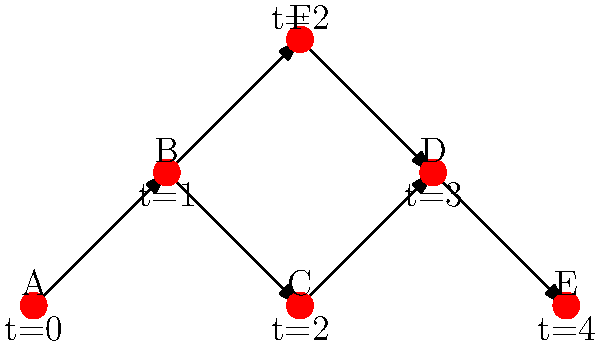In the given cloud instance network diagram, a cyber attack originates at instance A and propagates through the network. Each edge represents a connection between instances, and the time (t) indicates when each instance becomes infected. What is the minimum number of instances that need to be isolated to completely contain the spread of the attack after time t=2? To solve this problem, we need to analyze the propagation of the attack and identify the critical nodes that, if isolated, would prevent further spread. Let's break it down step-by-step:

1. At t=0, instance A is infected.
2. At t=1, the attack spreads to instance B.
3. At t=2, the attack reaches instances C and F simultaneously.
4. After t=2, we need to prevent the attack from spreading further.

To contain the spread, we need to cut off all paths from infected instances to uninfected ones. Let's examine the remaining paths:

5. From C, the attack can spread to D.
6. From F, the attack can also spread to D.
7. From D, the attack can spread to E.

To minimize the number of instances to isolate, we should focus on the node that appears in multiple paths: D.

8. By isolating instance D, we prevent the attack from spreading to E.
9. This single isolation cuts off both paths from C and F to the rest of the network.

Therefore, isolating just one instance (D) after t=2 is sufficient to contain the spread of the attack.
Answer: 1 (instance D) 